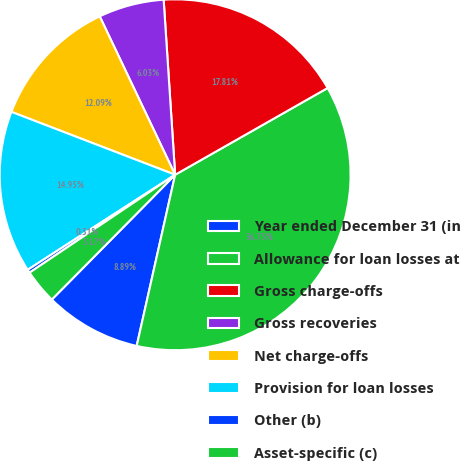Convert chart. <chart><loc_0><loc_0><loc_500><loc_500><pie_chart><fcel>Year ended December 31 (in<fcel>Allowance for loan losses at<fcel>Gross charge-offs<fcel>Gross recoveries<fcel>Net charge-offs<fcel>Provision for loan losses<fcel>Other (b)<fcel>Asset-specific (c)<nl><fcel>8.89%<fcel>36.75%<fcel>17.81%<fcel>6.03%<fcel>12.09%<fcel>14.95%<fcel>0.31%<fcel>3.17%<nl></chart> 